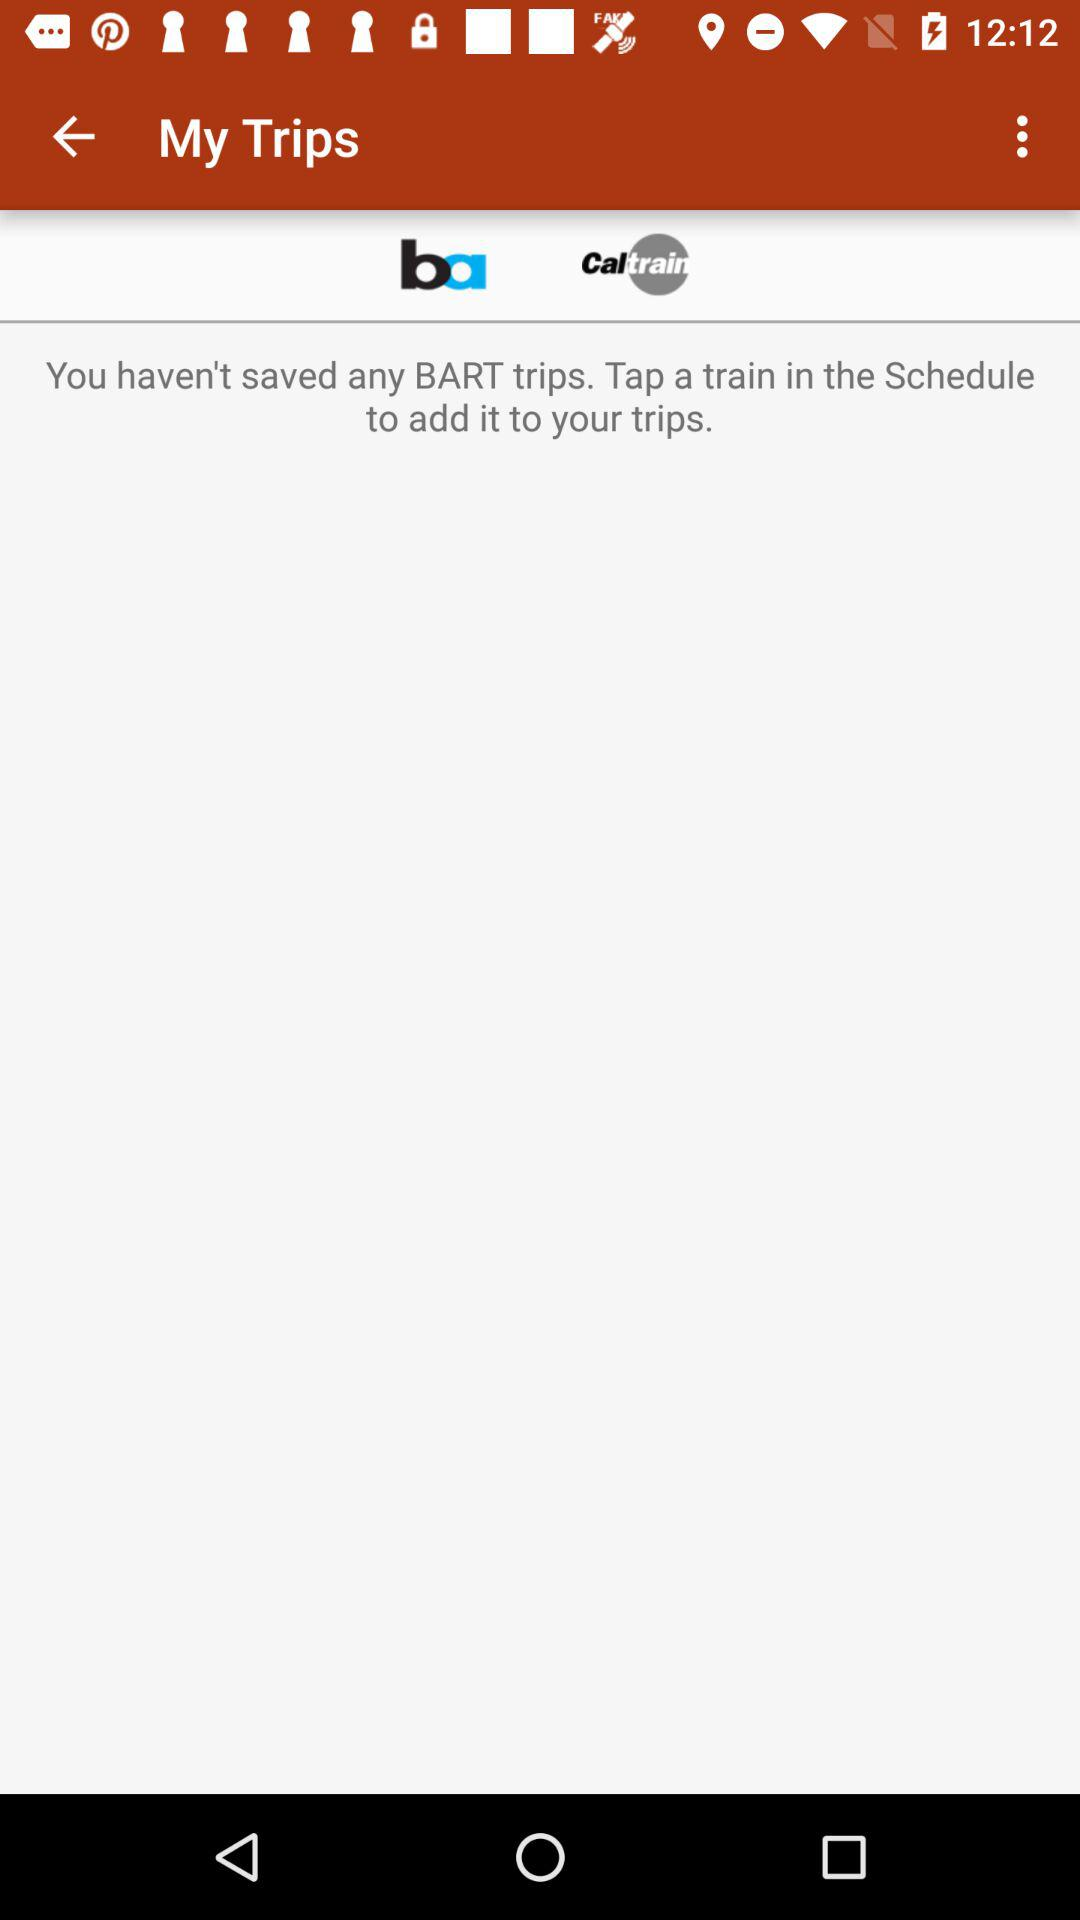What do we need to tap to add to our trips if we do not have any saved "BART" trips? You need to tap a train in the schedule to add it to your trips if you do not have any saved "BART" trips. 